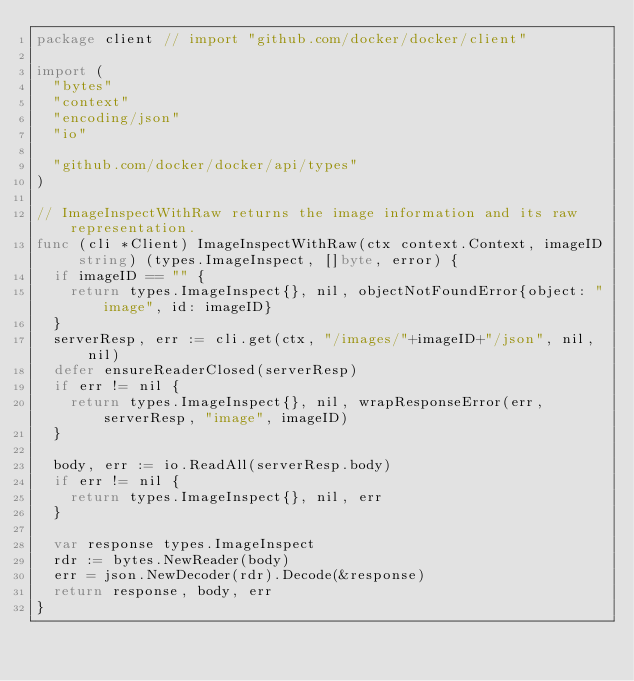Convert code to text. <code><loc_0><loc_0><loc_500><loc_500><_Go_>package client // import "github.com/docker/docker/client"

import (
	"bytes"
	"context"
	"encoding/json"
	"io"

	"github.com/docker/docker/api/types"
)

// ImageInspectWithRaw returns the image information and its raw representation.
func (cli *Client) ImageInspectWithRaw(ctx context.Context, imageID string) (types.ImageInspect, []byte, error) {
	if imageID == "" {
		return types.ImageInspect{}, nil, objectNotFoundError{object: "image", id: imageID}
	}
	serverResp, err := cli.get(ctx, "/images/"+imageID+"/json", nil, nil)
	defer ensureReaderClosed(serverResp)
	if err != nil {
		return types.ImageInspect{}, nil, wrapResponseError(err, serverResp, "image", imageID)
	}

	body, err := io.ReadAll(serverResp.body)
	if err != nil {
		return types.ImageInspect{}, nil, err
	}

	var response types.ImageInspect
	rdr := bytes.NewReader(body)
	err = json.NewDecoder(rdr).Decode(&response)
	return response, body, err
}
</code> 